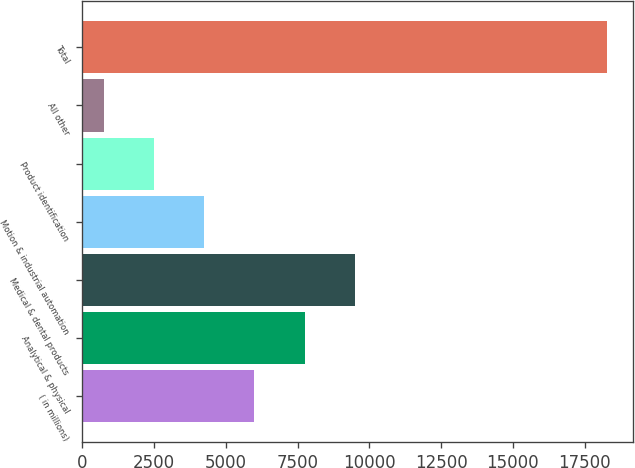Convert chart. <chart><loc_0><loc_0><loc_500><loc_500><bar_chart><fcel>( in millions)<fcel>Analytical & physical<fcel>Medical & dental products<fcel>Motion & industrial automation<fcel>Product identification<fcel>All other<fcel>Total<nl><fcel>6001.58<fcel>7752.84<fcel>9504.1<fcel>4250.32<fcel>2499.06<fcel>747.8<fcel>18260.4<nl></chart> 